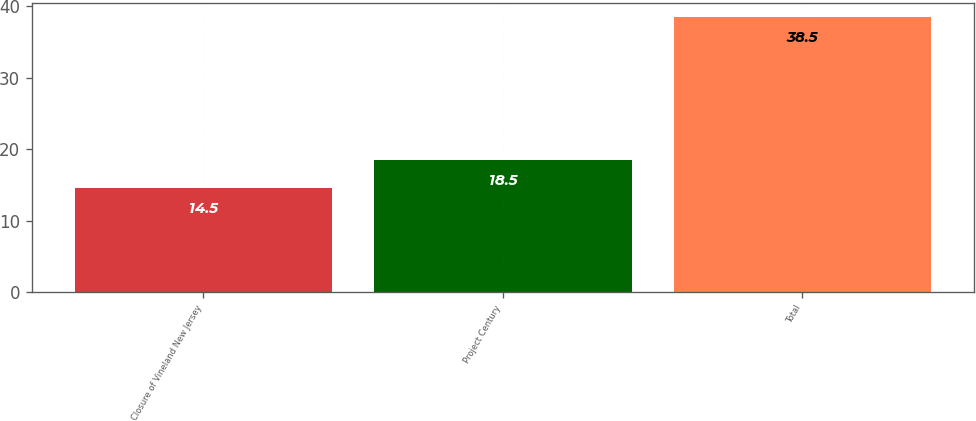Convert chart to OTSL. <chart><loc_0><loc_0><loc_500><loc_500><bar_chart><fcel>Closure of Vineland New Jersey<fcel>Project Century<fcel>Total<nl><fcel>14.5<fcel>18.5<fcel>38.5<nl></chart> 